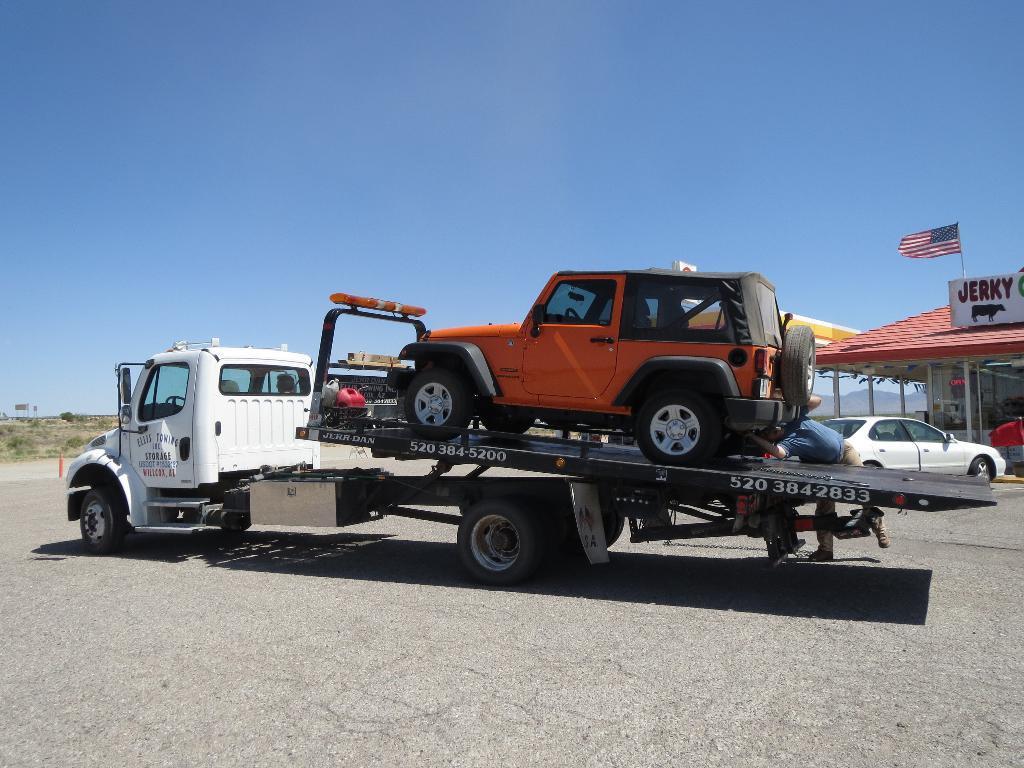Could you give a brief overview of what you see in this image? In this picture there is a white color lorry, carrying an orange color jeep in its truck, on the road. In the background there is a car parked here. We can observe a building here, on which there is a flag. In the background there is a sky. 